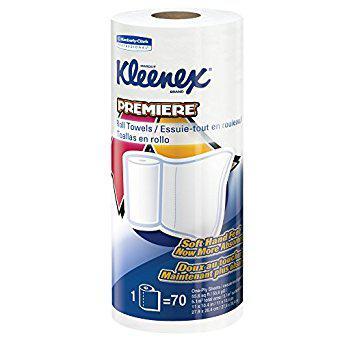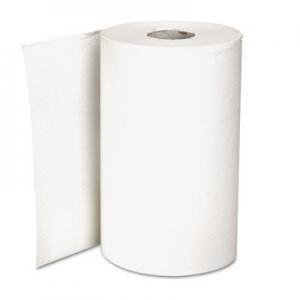The first image is the image on the left, the second image is the image on the right. Given the left and right images, does the statement "One of the roll of paper towels is not in its wrapper." hold true? Answer yes or no. Yes. The first image is the image on the left, the second image is the image on the right. Evaluate the accuracy of this statement regarding the images: "In at least one image there are two or more rolls of paper towels in each package.". Is it true? Answer yes or no. No. 